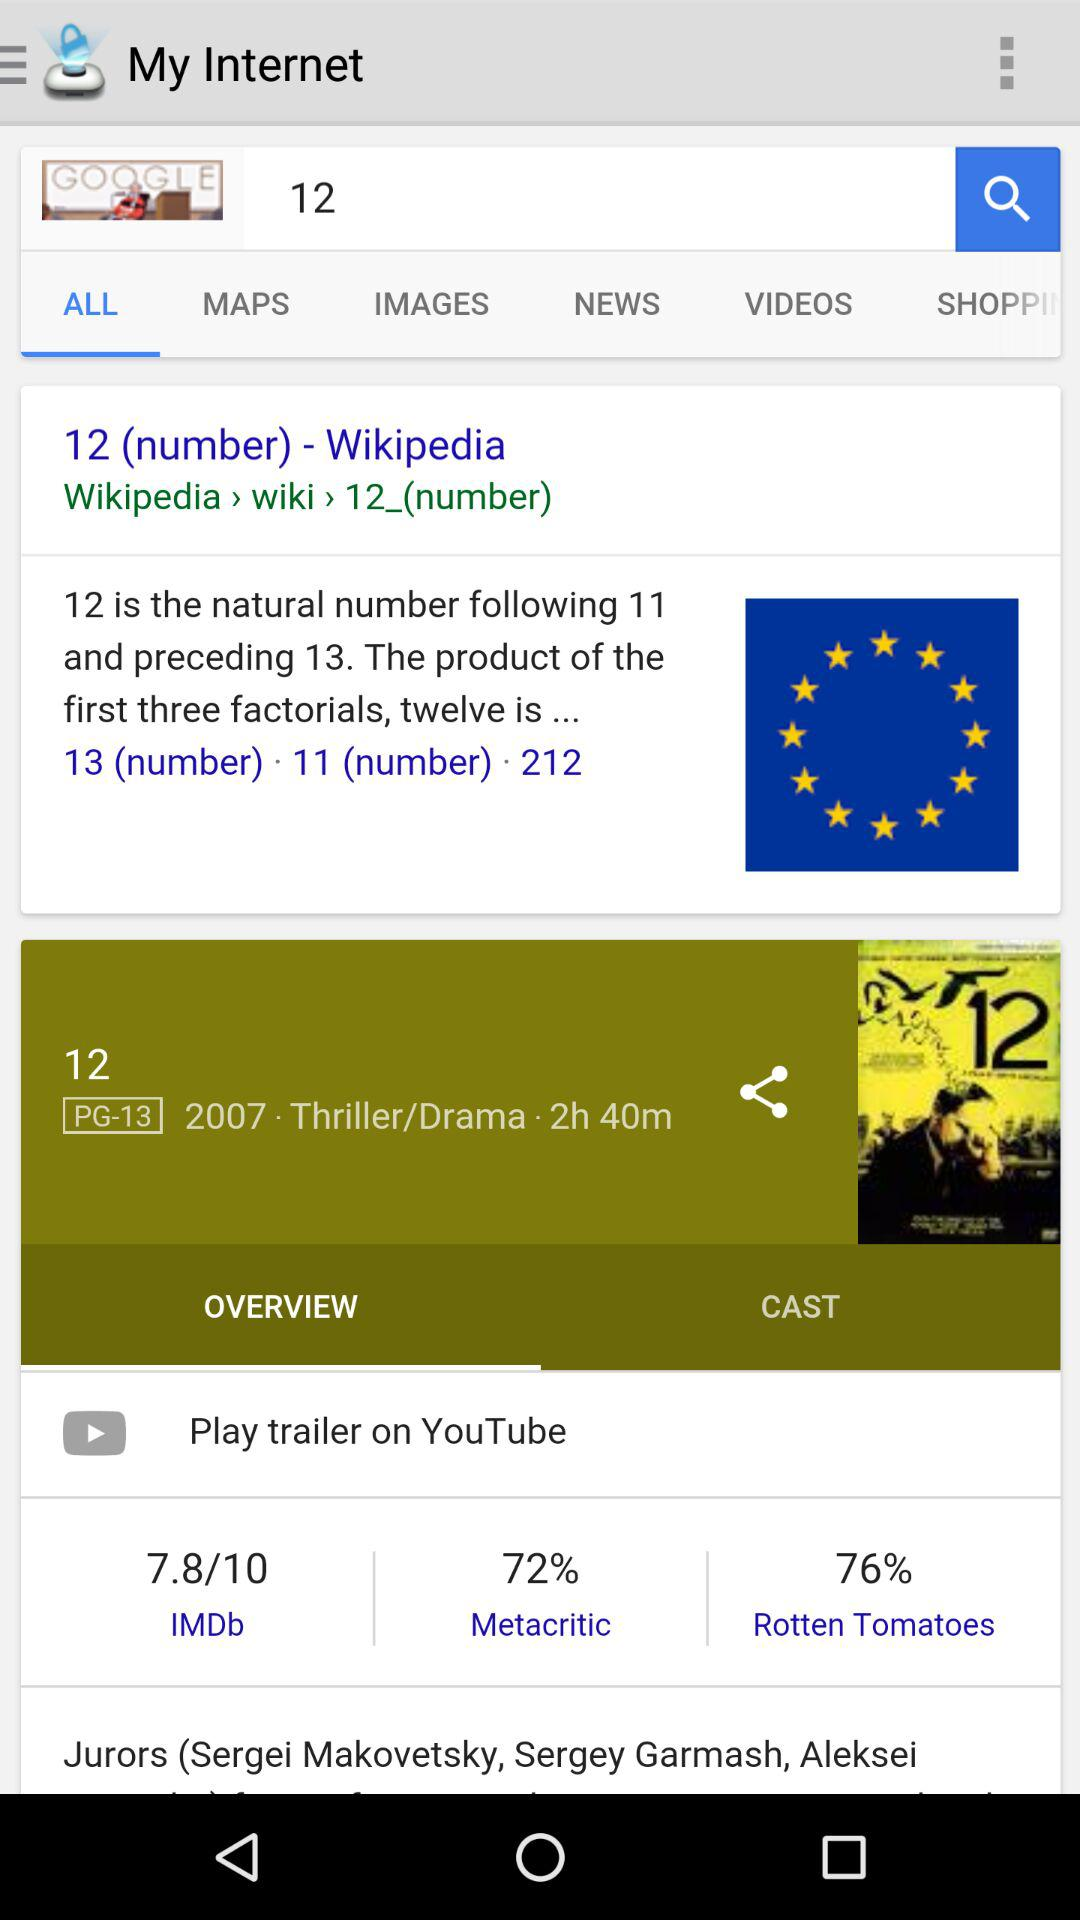What is the "Rotten Tomatoes" percentage? The "Rotten Tomatoes" percentage is 76. 